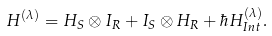<formula> <loc_0><loc_0><loc_500><loc_500>H ^ { ( \lambda ) } = H _ { S } \otimes I _ { R } + I _ { S } \otimes H _ { R } + \hbar { H } _ { I n t } ^ { ( \lambda ) } .</formula> 